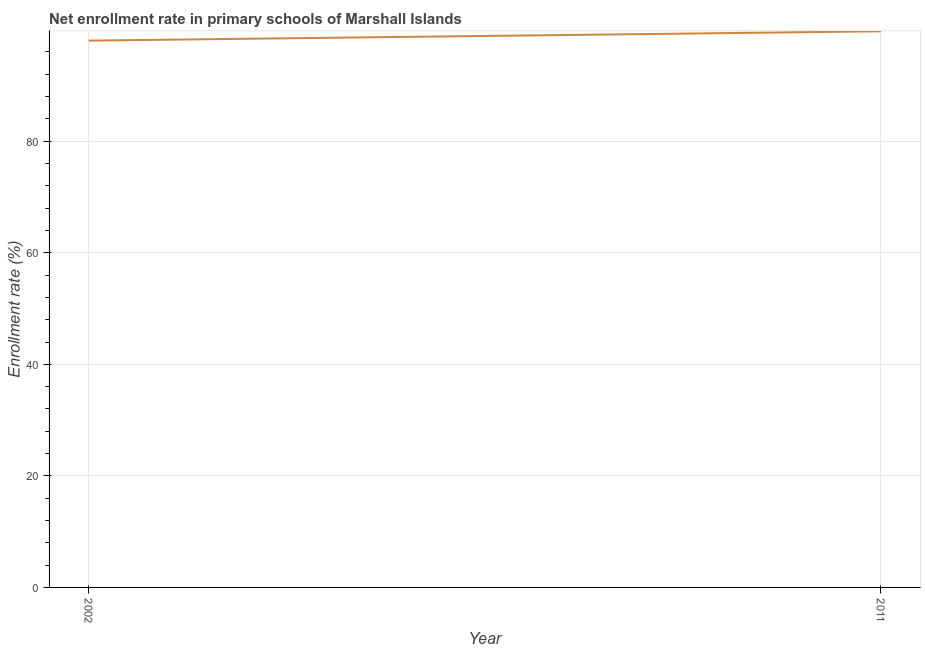What is the net enrollment rate in primary schools in 2011?
Your answer should be very brief. 99.71. Across all years, what is the maximum net enrollment rate in primary schools?
Keep it short and to the point. 99.71. Across all years, what is the minimum net enrollment rate in primary schools?
Provide a short and direct response. 98.03. In which year was the net enrollment rate in primary schools maximum?
Give a very brief answer. 2011. In which year was the net enrollment rate in primary schools minimum?
Your response must be concise. 2002. What is the sum of the net enrollment rate in primary schools?
Your answer should be very brief. 197.74. What is the difference between the net enrollment rate in primary schools in 2002 and 2011?
Offer a very short reply. -1.68. What is the average net enrollment rate in primary schools per year?
Make the answer very short. 98.87. What is the median net enrollment rate in primary schools?
Your answer should be compact. 98.87. In how many years, is the net enrollment rate in primary schools greater than 56 %?
Offer a very short reply. 2. Do a majority of the years between 2011 and 2002 (inclusive) have net enrollment rate in primary schools greater than 52 %?
Offer a terse response. No. What is the ratio of the net enrollment rate in primary schools in 2002 to that in 2011?
Provide a short and direct response. 0.98. Is the net enrollment rate in primary schools in 2002 less than that in 2011?
Make the answer very short. Yes. Does the net enrollment rate in primary schools monotonically increase over the years?
Ensure brevity in your answer.  Yes. Are the values on the major ticks of Y-axis written in scientific E-notation?
Offer a terse response. No. What is the title of the graph?
Provide a short and direct response. Net enrollment rate in primary schools of Marshall Islands. What is the label or title of the Y-axis?
Your answer should be very brief. Enrollment rate (%). What is the Enrollment rate (%) of 2002?
Ensure brevity in your answer.  98.03. What is the Enrollment rate (%) in 2011?
Your response must be concise. 99.71. What is the difference between the Enrollment rate (%) in 2002 and 2011?
Provide a succinct answer. -1.68. What is the ratio of the Enrollment rate (%) in 2002 to that in 2011?
Your response must be concise. 0.98. 